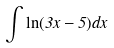Convert formula to latex. <formula><loc_0><loc_0><loc_500><loc_500>\int \ln ( 3 x - 5 ) d x</formula> 